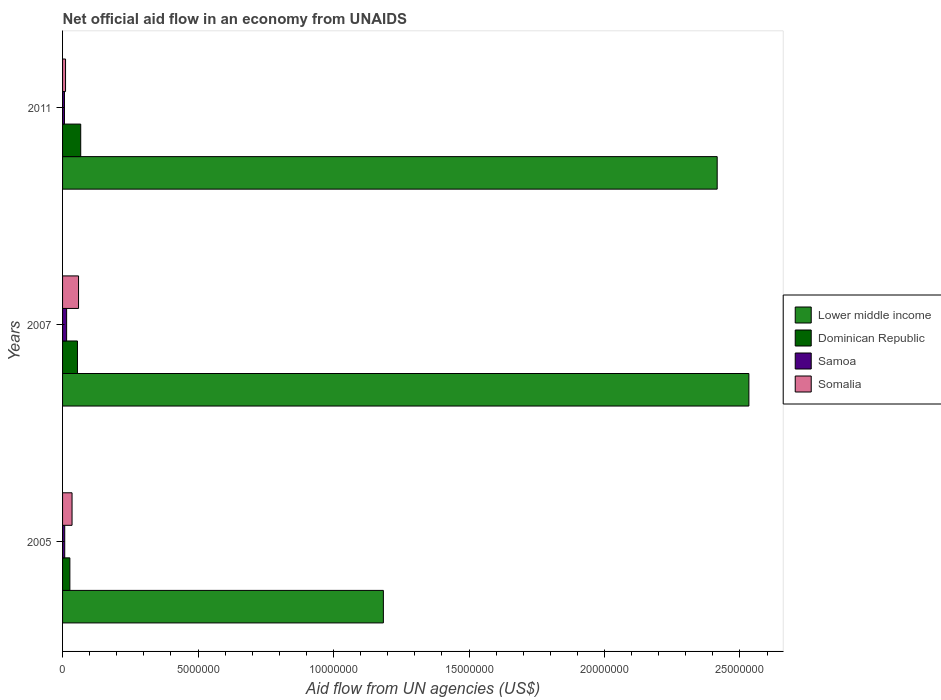How many different coloured bars are there?
Your answer should be compact. 4. How many groups of bars are there?
Offer a very short reply. 3. Are the number of bars on each tick of the Y-axis equal?
Offer a terse response. Yes. How many bars are there on the 1st tick from the bottom?
Offer a terse response. 4. What is the label of the 1st group of bars from the top?
Make the answer very short. 2011. In how many cases, is the number of bars for a given year not equal to the number of legend labels?
Provide a succinct answer. 0. Across all years, what is the minimum net official aid flow in Samoa?
Offer a terse response. 7.00e+04. In which year was the net official aid flow in Samoa maximum?
Your answer should be very brief. 2007. What is the total net official aid flow in Somalia in the graph?
Ensure brevity in your answer.  1.05e+06. What is the difference between the net official aid flow in Dominican Republic in 2005 and that in 2011?
Offer a very short reply. -4.00e+05. What is the difference between the net official aid flow in Lower middle income in 2005 and the net official aid flow in Dominican Republic in 2007?
Provide a short and direct response. 1.13e+07. In the year 2007, what is the difference between the net official aid flow in Somalia and net official aid flow in Lower middle income?
Keep it short and to the point. -2.47e+07. What is the ratio of the net official aid flow in Samoa in 2005 to that in 2011?
Keep it short and to the point. 1.14. Is the net official aid flow in Samoa in 2007 less than that in 2011?
Ensure brevity in your answer.  No. What is the difference between the highest and the second highest net official aid flow in Somalia?
Offer a very short reply. 2.40e+05. What is the difference between the highest and the lowest net official aid flow in Somalia?
Keep it short and to the point. 4.80e+05. In how many years, is the net official aid flow in Lower middle income greater than the average net official aid flow in Lower middle income taken over all years?
Ensure brevity in your answer.  2. What does the 2nd bar from the top in 2007 represents?
Make the answer very short. Samoa. What does the 3rd bar from the bottom in 2007 represents?
Provide a short and direct response. Samoa. How many bars are there?
Keep it short and to the point. 12. Are the values on the major ticks of X-axis written in scientific E-notation?
Ensure brevity in your answer.  No. What is the title of the graph?
Give a very brief answer. Net official aid flow in an economy from UNAIDS. What is the label or title of the X-axis?
Give a very brief answer. Aid flow from UN agencies (US$). What is the label or title of the Y-axis?
Provide a short and direct response. Years. What is the Aid flow from UN agencies (US$) in Lower middle income in 2005?
Make the answer very short. 1.18e+07. What is the Aid flow from UN agencies (US$) in Dominican Republic in 2005?
Your answer should be very brief. 2.70e+05. What is the Aid flow from UN agencies (US$) of Samoa in 2005?
Your answer should be compact. 8.00e+04. What is the Aid flow from UN agencies (US$) of Somalia in 2005?
Keep it short and to the point. 3.50e+05. What is the Aid flow from UN agencies (US$) of Lower middle income in 2007?
Give a very brief answer. 2.53e+07. What is the Aid flow from UN agencies (US$) of Somalia in 2007?
Keep it short and to the point. 5.90e+05. What is the Aid flow from UN agencies (US$) in Lower middle income in 2011?
Ensure brevity in your answer.  2.42e+07. What is the Aid flow from UN agencies (US$) of Dominican Republic in 2011?
Offer a very short reply. 6.70e+05. Across all years, what is the maximum Aid flow from UN agencies (US$) in Lower middle income?
Provide a succinct answer. 2.53e+07. Across all years, what is the maximum Aid flow from UN agencies (US$) of Dominican Republic?
Your response must be concise. 6.70e+05. Across all years, what is the maximum Aid flow from UN agencies (US$) of Somalia?
Give a very brief answer. 5.90e+05. Across all years, what is the minimum Aid flow from UN agencies (US$) of Lower middle income?
Give a very brief answer. 1.18e+07. Across all years, what is the minimum Aid flow from UN agencies (US$) of Dominican Republic?
Keep it short and to the point. 2.70e+05. What is the total Aid flow from UN agencies (US$) of Lower middle income in the graph?
Give a very brief answer. 6.13e+07. What is the total Aid flow from UN agencies (US$) in Dominican Republic in the graph?
Your answer should be very brief. 1.49e+06. What is the total Aid flow from UN agencies (US$) of Samoa in the graph?
Give a very brief answer. 3.00e+05. What is the total Aid flow from UN agencies (US$) of Somalia in the graph?
Keep it short and to the point. 1.05e+06. What is the difference between the Aid flow from UN agencies (US$) in Lower middle income in 2005 and that in 2007?
Your answer should be very brief. -1.35e+07. What is the difference between the Aid flow from UN agencies (US$) in Dominican Republic in 2005 and that in 2007?
Your response must be concise. -2.80e+05. What is the difference between the Aid flow from UN agencies (US$) in Samoa in 2005 and that in 2007?
Your answer should be very brief. -7.00e+04. What is the difference between the Aid flow from UN agencies (US$) in Somalia in 2005 and that in 2007?
Your answer should be very brief. -2.40e+05. What is the difference between the Aid flow from UN agencies (US$) in Lower middle income in 2005 and that in 2011?
Offer a terse response. -1.23e+07. What is the difference between the Aid flow from UN agencies (US$) in Dominican Republic in 2005 and that in 2011?
Provide a short and direct response. -4.00e+05. What is the difference between the Aid flow from UN agencies (US$) of Samoa in 2005 and that in 2011?
Your answer should be compact. 10000. What is the difference between the Aid flow from UN agencies (US$) of Lower middle income in 2007 and that in 2011?
Provide a short and direct response. 1.17e+06. What is the difference between the Aid flow from UN agencies (US$) of Dominican Republic in 2007 and that in 2011?
Keep it short and to the point. -1.20e+05. What is the difference between the Aid flow from UN agencies (US$) of Somalia in 2007 and that in 2011?
Provide a short and direct response. 4.80e+05. What is the difference between the Aid flow from UN agencies (US$) in Lower middle income in 2005 and the Aid flow from UN agencies (US$) in Dominican Republic in 2007?
Keep it short and to the point. 1.13e+07. What is the difference between the Aid flow from UN agencies (US$) of Lower middle income in 2005 and the Aid flow from UN agencies (US$) of Samoa in 2007?
Offer a very short reply. 1.17e+07. What is the difference between the Aid flow from UN agencies (US$) in Lower middle income in 2005 and the Aid flow from UN agencies (US$) in Somalia in 2007?
Your answer should be compact. 1.12e+07. What is the difference between the Aid flow from UN agencies (US$) of Dominican Republic in 2005 and the Aid flow from UN agencies (US$) of Samoa in 2007?
Your response must be concise. 1.20e+05. What is the difference between the Aid flow from UN agencies (US$) of Dominican Republic in 2005 and the Aid flow from UN agencies (US$) of Somalia in 2007?
Offer a very short reply. -3.20e+05. What is the difference between the Aid flow from UN agencies (US$) in Samoa in 2005 and the Aid flow from UN agencies (US$) in Somalia in 2007?
Make the answer very short. -5.10e+05. What is the difference between the Aid flow from UN agencies (US$) in Lower middle income in 2005 and the Aid flow from UN agencies (US$) in Dominican Republic in 2011?
Your answer should be very brief. 1.12e+07. What is the difference between the Aid flow from UN agencies (US$) of Lower middle income in 2005 and the Aid flow from UN agencies (US$) of Samoa in 2011?
Ensure brevity in your answer.  1.18e+07. What is the difference between the Aid flow from UN agencies (US$) of Lower middle income in 2005 and the Aid flow from UN agencies (US$) of Somalia in 2011?
Make the answer very short. 1.17e+07. What is the difference between the Aid flow from UN agencies (US$) in Dominican Republic in 2005 and the Aid flow from UN agencies (US$) in Samoa in 2011?
Keep it short and to the point. 2.00e+05. What is the difference between the Aid flow from UN agencies (US$) in Dominican Republic in 2005 and the Aid flow from UN agencies (US$) in Somalia in 2011?
Provide a short and direct response. 1.60e+05. What is the difference between the Aid flow from UN agencies (US$) in Lower middle income in 2007 and the Aid flow from UN agencies (US$) in Dominican Republic in 2011?
Your response must be concise. 2.47e+07. What is the difference between the Aid flow from UN agencies (US$) of Lower middle income in 2007 and the Aid flow from UN agencies (US$) of Samoa in 2011?
Provide a succinct answer. 2.53e+07. What is the difference between the Aid flow from UN agencies (US$) in Lower middle income in 2007 and the Aid flow from UN agencies (US$) in Somalia in 2011?
Provide a short and direct response. 2.52e+07. What is the difference between the Aid flow from UN agencies (US$) of Dominican Republic in 2007 and the Aid flow from UN agencies (US$) of Samoa in 2011?
Your answer should be very brief. 4.80e+05. What is the difference between the Aid flow from UN agencies (US$) of Dominican Republic in 2007 and the Aid flow from UN agencies (US$) of Somalia in 2011?
Provide a succinct answer. 4.40e+05. What is the difference between the Aid flow from UN agencies (US$) of Samoa in 2007 and the Aid flow from UN agencies (US$) of Somalia in 2011?
Your answer should be very brief. 4.00e+04. What is the average Aid flow from UN agencies (US$) of Lower middle income per year?
Make the answer very short. 2.04e+07. What is the average Aid flow from UN agencies (US$) of Dominican Republic per year?
Make the answer very short. 4.97e+05. What is the average Aid flow from UN agencies (US$) of Samoa per year?
Ensure brevity in your answer.  1.00e+05. In the year 2005, what is the difference between the Aid flow from UN agencies (US$) in Lower middle income and Aid flow from UN agencies (US$) in Dominican Republic?
Offer a terse response. 1.16e+07. In the year 2005, what is the difference between the Aid flow from UN agencies (US$) of Lower middle income and Aid flow from UN agencies (US$) of Samoa?
Your answer should be compact. 1.18e+07. In the year 2005, what is the difference between the Aid flow from UN agencies (US$) in Lower middle income and Aid flow from UN agencies (US$) in Somalia?
Give a very brief answer. 1.15e+07. In the year 2005, what is the difference between the Aid flow from UN agencies (US$) in Dominican Republic and Aid flow from UN agencies (US$) in Somalia?
Give a very brief answer. -8.00e+04. In the year 2005, what is the difference between the Aid flow from UN agencies (US$) of Samoa and Aid flow from UN agencies (US$) of Somalia?
Your answer should be very brief. -2.70e+05. In the year 2007, what is the difference between the Aid flow from UN agencies (US$) of Lower middle income and Aid flow from UN agencies (US$) of Dominican Republic?
Ensure brevity in your answer.  2.48e+07. In the year 2007, what is the difference between the Aid flow from UN agencies (US$) of Lower middle income and Aid flow from UN agencies (US$) of Samoa?
Provide a short and direct response. 2.52e+07. In the year 2007, what is the difference between the Aid flow from UN agencies (US$) in Lower middle income and Aid flow from UN agencies (US$) in Somalia?
Make the answer very short. 2.47e+07. In the year 2007, what is the difference between the Aid flow from UN agencies (US$) of Dominican Republic and Aid flow from UN agencies (US$) of Samoa?
Your answer should be compact. 4.00e+05. In the year 2007, what is the difference between the Aid flow from UN agencies (US$) of Dominican Republic and Aid flow from UN agencies (US$) of Somalia?
Your answer should be compact. -4.00e+04. In the year 2007, what is the difference between the Aid flow from UN agencies (US$) in Samoa and Aid flow from UN agencies (US$) in Somalia?
Keep it short and to the point. -4.40e+05. In the year 2011, what is the difference between the Aid flow from UN agencies (US$) in Lower middle income and Aid flow from UN agencies (US$) in Dominican Republic?
Provide a succinct answer. 2.35e+07. In the year 2011, what is the difference between the Aid flow from UN agencies (US$) of Lower middle income and Aid flow from UN agencies (US$) of Samoa?
Offer a very short reply. 2.41e+07. In the year 2011, what is the difference between the Aid flow from UN agencies (US$) in Lower middle income and Aid flow from UN agencies (US$) in Somalia?
Ensure brevity in your answer.  2.40e+07. In the year 2011, what is the difference between the Aid flow from UN agencies (US$) in Dominican Republic and Aid flow from UN agencies (US$) in Somalia?
Offer a very short reply. 5.60e+05. What is the ratio of the Aid flow from UN agencies (US$) in Lower middle income in 2005 to that in 2007?
Give a very brief answer. 0.47. What is the ratio of the Aid flow from UN agencies (US$) of Dominican Republic in 2005 to that in 2007?
Your answer should be very brief. 0.49. What is the ratio of the Aid flow from UN agencies (US$) of Samoa in 2005 to that in 2007?
Provide a succinct answer. 0.53. What is the ratio of the Aid flow from UN agencies (US$) in Somalia in 2005 to that in 2007?
Give a very brief answer. 0.59. What is the ratio of the Aid flow from UN agencies (US$) of Lower middle income in 2005 to that in 2011?
Give a very brief answer. 0.49. What is the ratio of the Aid flow from UN agencies (US$) of Dominican Republic in 2005 to that in 2011?
Provide a succinct answer. 0.4. What is the ratio of the Aid flow from UN agencies (US$) of Samoa in 2005 to that in 2011?
Your answer should be very brief. 1.14. What is the ratio of the Aid flow from UN agencies (US$) of Somalia in 2005 to that in 2011?
Provide a short and direct response. 3.18. What is the ratio of the Aid flow from UN agencies (US$) in Lower middle income in 2007 to that in 2011?
Give a very brief answer. 1.05. What is the ratio of the Aid flow from UN agencies (US$) in Dominican Republic in 2007 to that in 2011?
Your answer should be compact. 0.82. What is the ratio of the Aid flow from UN agencies (US$) of Samoa in 2007 to that in 2011?
Your answer should be compact. 2.14. What is the ratio of the Aid flow from UN agencies (US$) in Somalia in 2007 to that in 2011?
Ensure brevity in your answer.  5.36. What is the difference between the highest and the second highest Aid flow from UN agencies (US$) of Lower middle income?
Provide a succinct answer. 1.17e+06. What is the difference between the highest and the second highest Aid flow from UN agencies (US$) in Samoa?
Provide a short and direct response. 7.00e+04. What is the difference between the highest and the second highest Aid flow from UN agencies (US$) of Somalia?
Provide a short and direct response. 2.40e+05. What is the difference between the highest and the lowest Aid flow from UN agencies (US$) in Lower middle income?
Your response must be concise. 1.35e+07. What is the difference between the highest and the lowest Aid flow from UN agencies (US$) of Samoa?
Provide a short and direct response. 8.00e+04. What is the difference between the highest and the lowest Aid flow from UN agencies (US$) in Somalia?
Offer a terse response. 4.80e+05. 